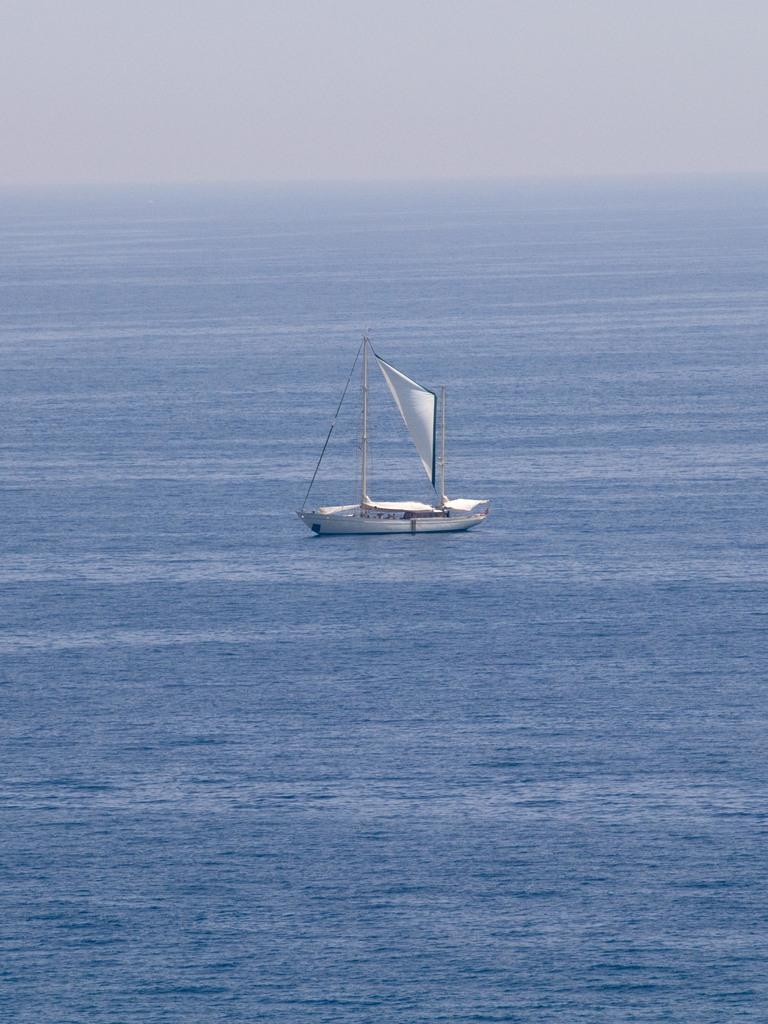Where was the picture taken? The picture was clicked outside the city. What is the main subject of the image? There is a sailboat in the center of the image. In which environment is the sailboat located? The sailboat appears to be in a water body. What can be seen in the background of the image? The sky is visible in the background of the image. How many feet of sugar can be seen on the sailboat in the image? There is no sugar or feet mentioned in the image; it features a sailboat in a water body with the sky visible in the background. 